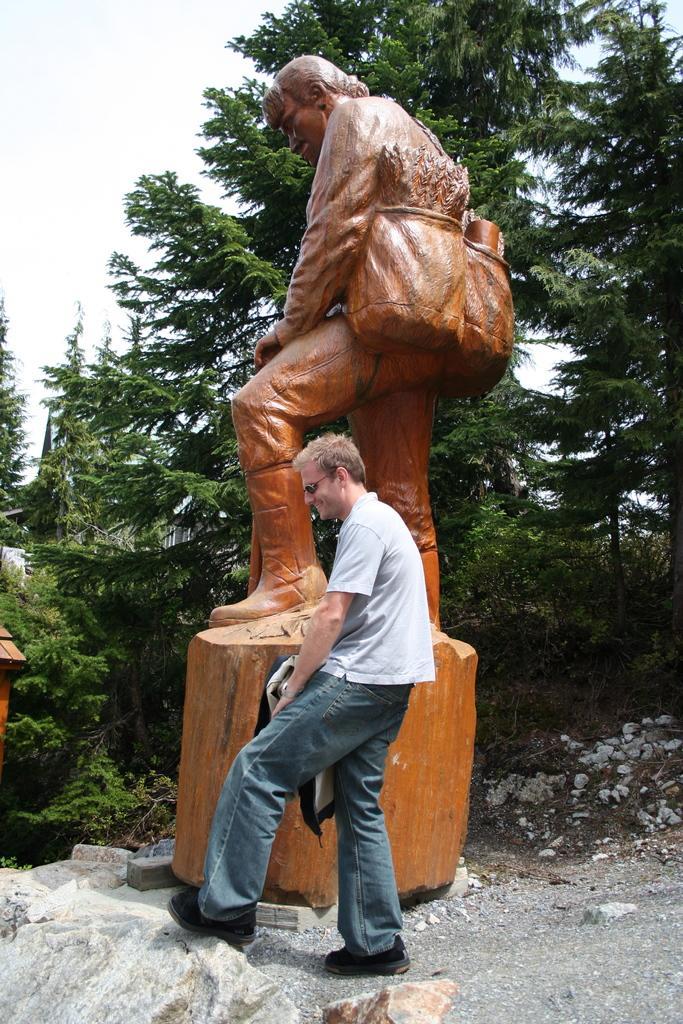Could you give a brief overview of what you see in this image? In the center of the image we can see a statue. In the foreground of the image we can see a person standing on the ground. In the background, we can see some rocks, group of trees and the sky. 